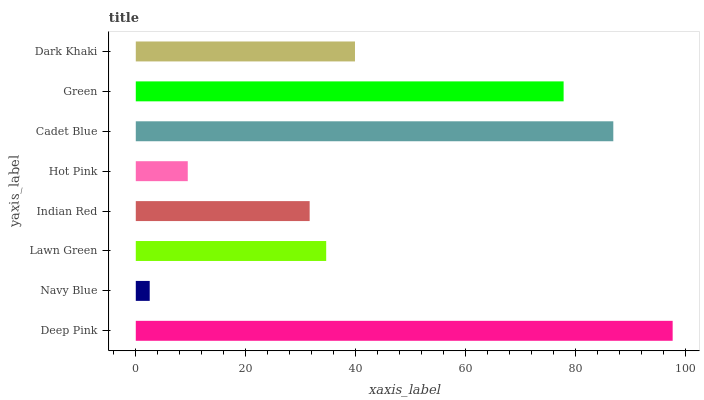Is Navy Blue the minimum?
Answer yes or no. Yes. Is Deep Pink the maximum?
Answer yes or no. Yes. Is Lawn Green the minimum?
Answer yes or no. No. Is Lawn Green the maximum?
Answer yes or no. No. Is Lawn Green greater than Navy Blue?
Answer yes or no. Yes. Is Navy Blue less than Lawn Green?
Answer yes or no. Yes. Is Navy Blue greater than Lawn Green?
Answer yes or no. No. Is Lawn Green less than Navy Blue?
Answer yes or no. No. Is Dark Khaki the high median?
Answer yes or no. Yes. Is Lawn Green the low median?
Answer yes or no. Yes. Is Green the high median?
Answer yes or no. No. Is Navy Blue the low median?
Answer yes or no. No. 